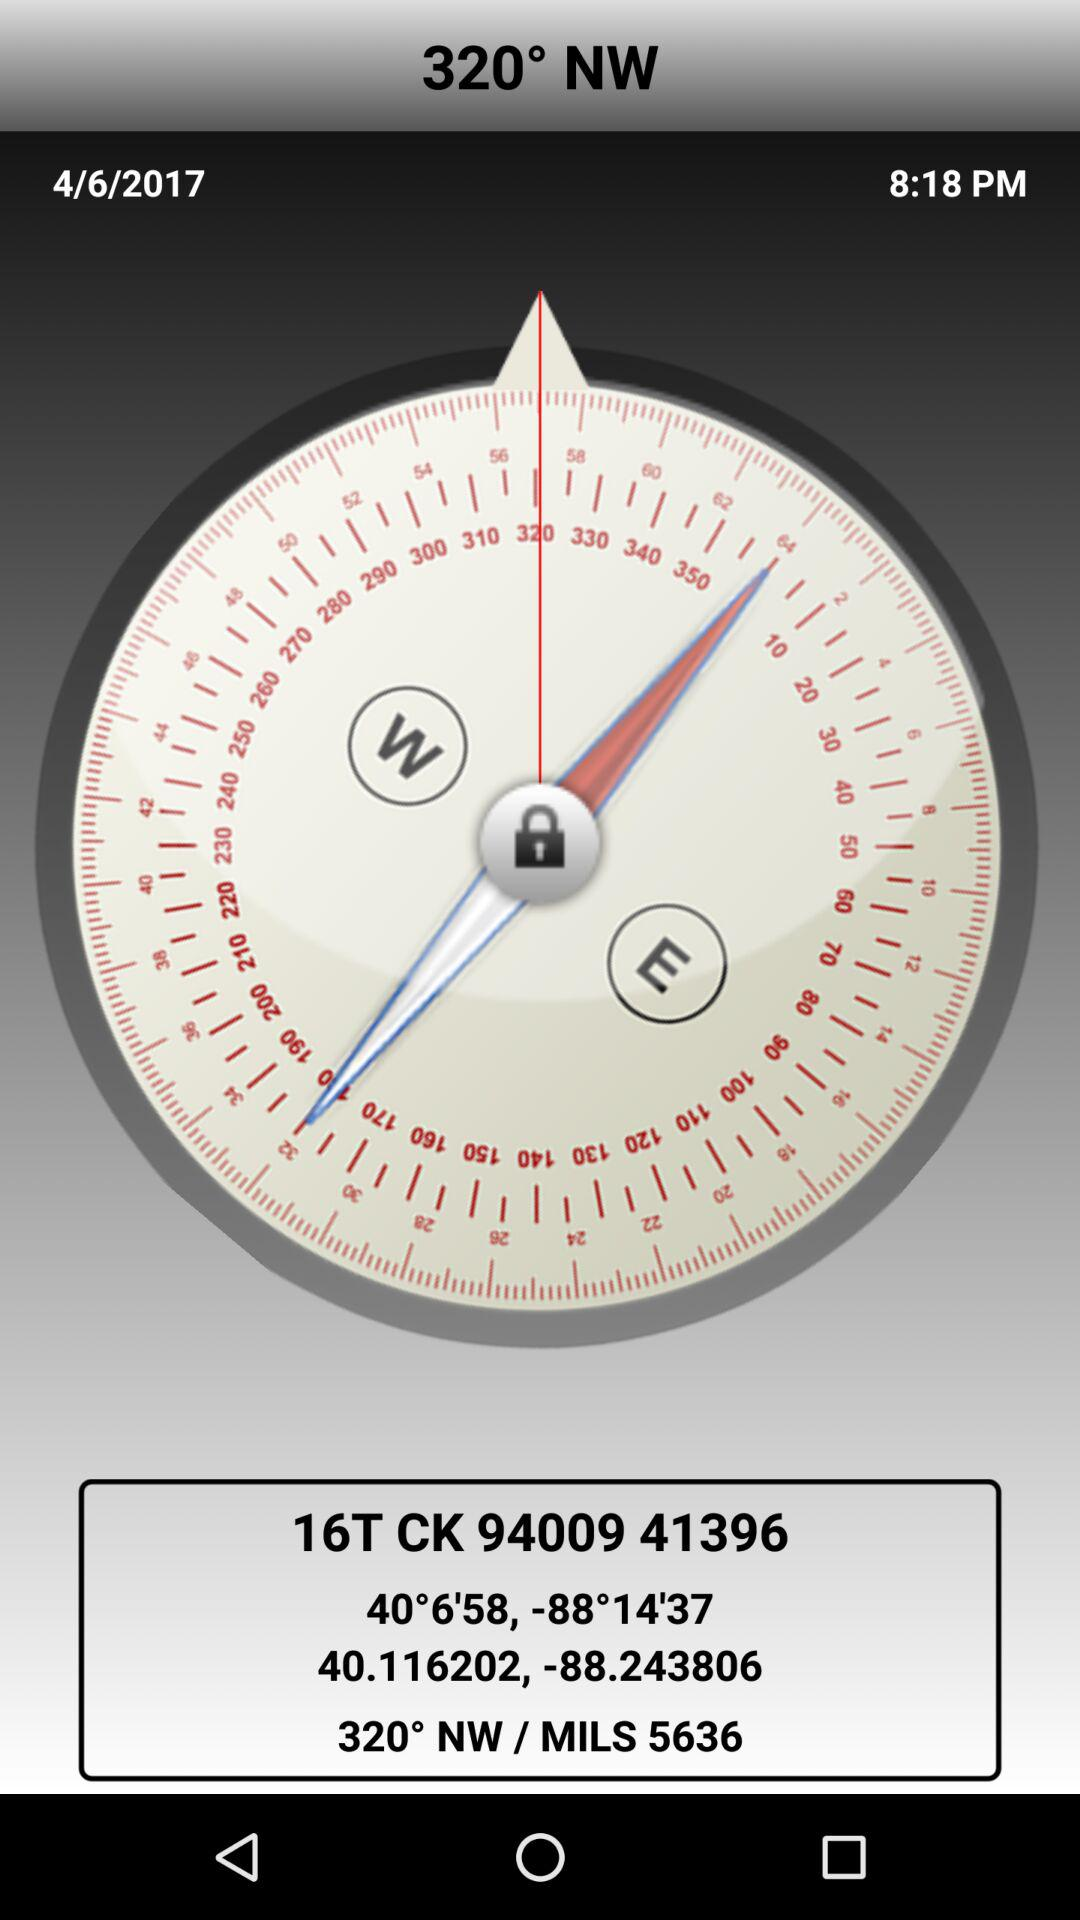What is the mentioned angle? The mentioned angle is 320°. 